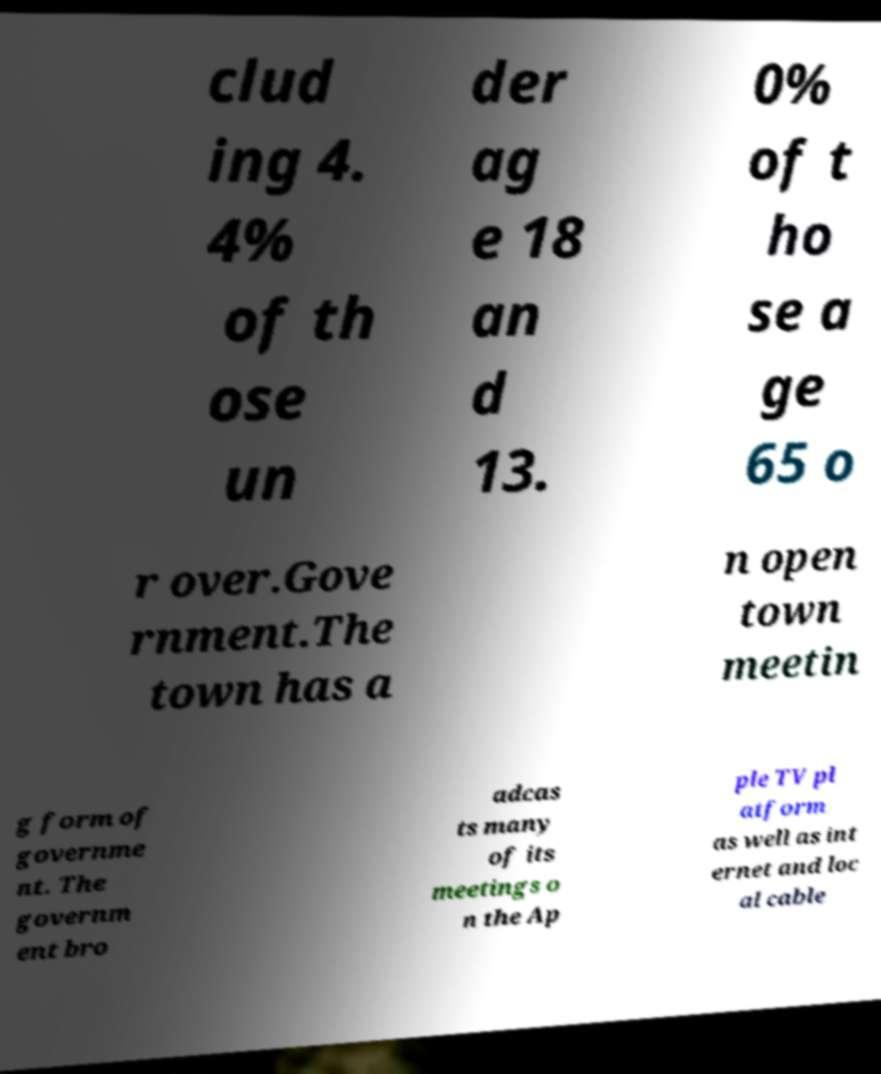Could you assist in decoding the text presented in this image and type it out clearly? clud ing 4. 4% of th ose un der ag e 18 an d 13. 0% of t ho se a ge 65 o r over.Gove rnment.The town has a n open town meetin g form of governme nt. The governm ent bro adcas ts many of its meetings o n the Ap ple TV pl atform as well as int ernet and loc al cable 